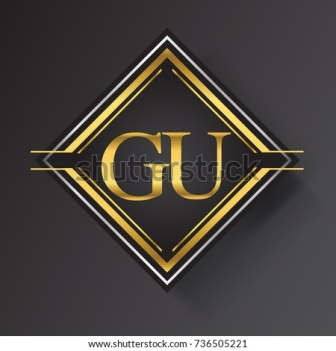This emblem looks quite striking. Can you tell me what it might symbolize? The diamond-shaped emblem with 'GU' could symbolize a brand or organization that prides itself on sophistication and elegance. The gold color often represents wealth, prestige, and high quality, suggesting that 'GU' may be associated with luxury products or services. The symmetry and 3D rendering imply meticulous attention to detail and a commitment to excellence. Interesting! Could it be related to any specific industry? Given the luxurious and refined design, this emblem could be associated with industries such as high-end fashion, jewelry, real estate, or even a prestigious educational institution. The serif font adds a touch of formality, supporting the idea that 'GU' is meant to convey trust, quality, and excellence within its industry. 